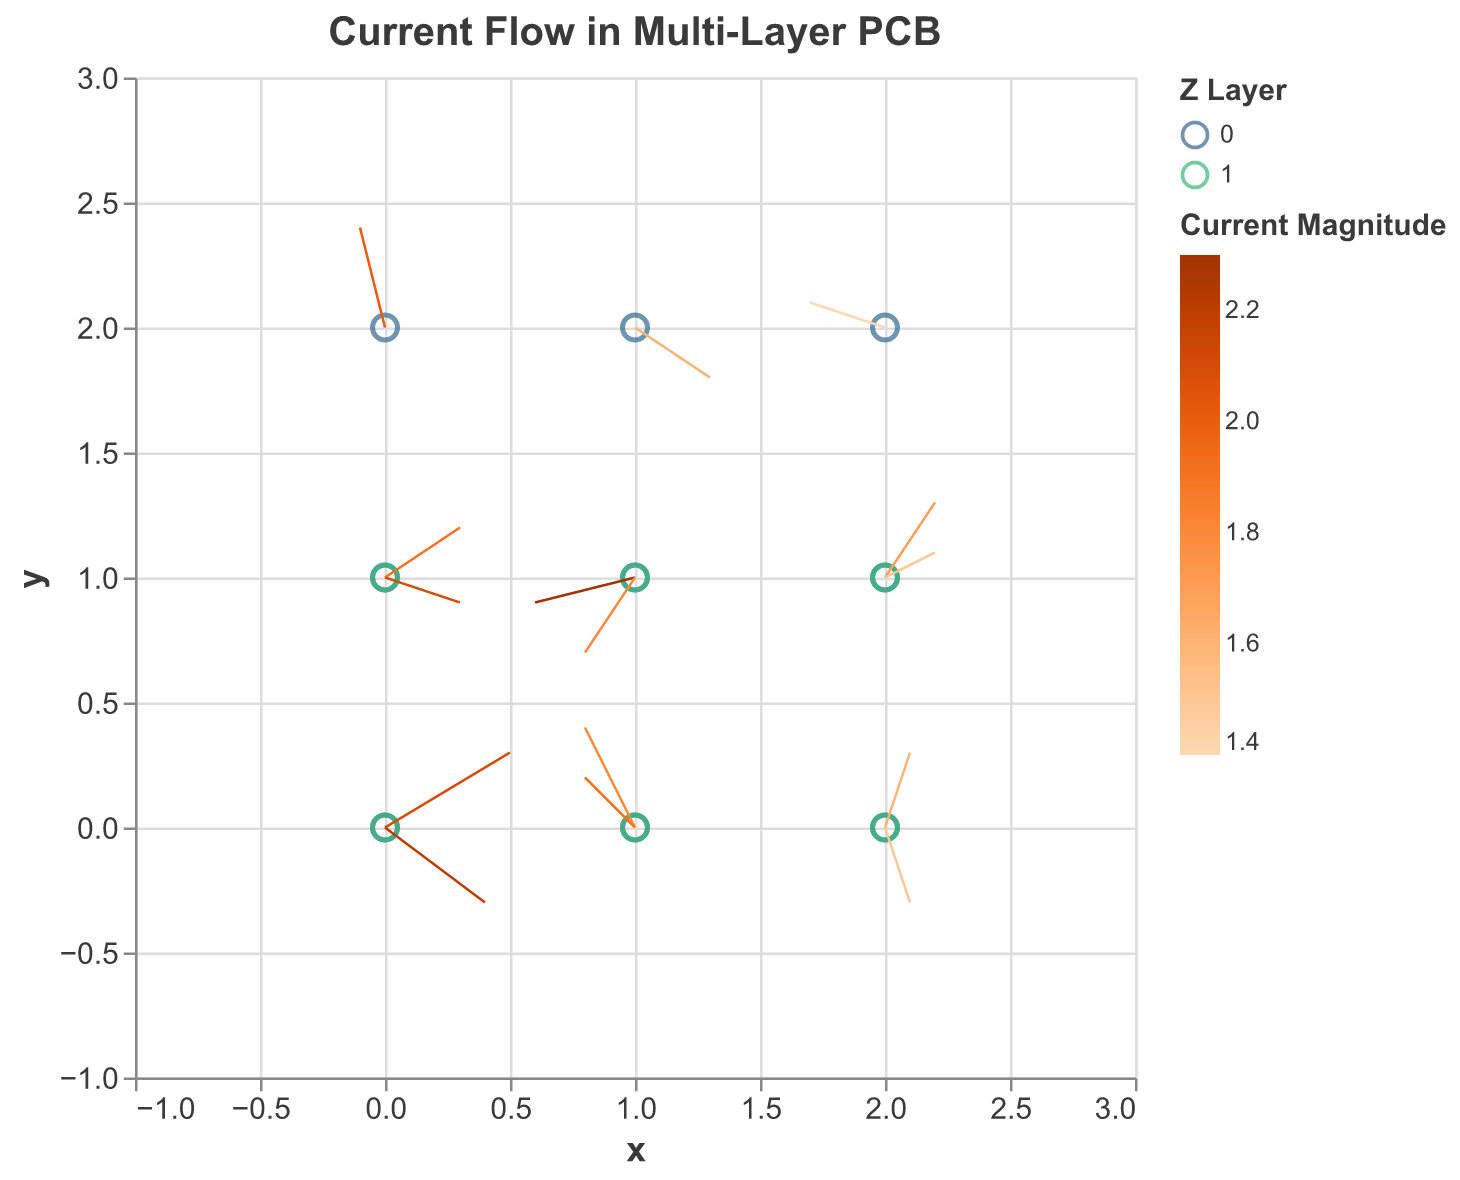What is the highest current magnitude shown in the figure? To identify the highest current magnitude, look at the color representing the magnitude values in the legend. The magnitude values for each arrow vary, but the highest value is 2.3, as indicated by the corresponding color shade in the plot.
Answer: 2.3 Which layer has the most points represented? There are three unique layers (z-values: 0, 1) as shown by the 'Z Layer' color legend. Both layers visually appear to have an equal number of points (each grid position corresponding to a different z-coordinate). Each layer has 7 data points.
Answer: 7 What is the general direction of current flow in the top layer (z = 1)? To determine the general direction of the current flow in the top layer, observe the directional arrows at points where z = 1. These arrows show varied directions, including positive and negative x, y, and z components.
Answer: Varied directions Compare the magnitudes of current flows at the point (1, 1) in both layers. Which one is higher? Check the current magnitudes at point (1, 1) for z = 0 and z = 1. The magnitudes are 2.3 for z = 0, and 1.8 for z = 1. As 2.3 > 1.8, the lower layer (z = 0) has a higher magnitude at (1, 1).
Answer: z = 0 What is the current direction and magnitude at (0, 0) in the bottom layer (z = 0)? Locate the vector at (0, 0) in the bottom layer (z = 0). The direction is given by the components (0.5, 0.3, 0.1), and the magnitude is 2.1, based on the values provided.
Answer: Direction: (0.5, 0.3, 0.1), Magnitude: 2.1 Which point has the smallest current magnitude value in the bottom layer (z = 0)? Check the current magnitudes for all points in the bottom layer (z = 0). The smallest magnitude among them is 1.4, located at point (2, 2).
Answer: (2, 2) At the point (2, 1) in the top layer (z = 1), what are the x and y components of the current flow? Look at the values associated with the point (2, 1, z=1). The x-component is 0.2 and the y-component is 0.1 as extracted from the dataset.
Answer: x: 0.2, y: 0.1 Calculate the average current magnitude in the bottom layer (z = 0). Identify and sum all magnitudes in the bottom layer (z = 0). There are 9 points: 2.1, 1.8, 1.5, 1.9, 2.3, 1.7, 2.0, 1.6, and 1.4. The sum is 2.1 + 1.8 + 1.5 + 1.9 + 2.3 + 1.7 + 2.0 + 1.6 + 1.4 = 16.3. Divided by 9, the average magnitude is 16.3/9 ≈ 1.81.
Answer: ~1.81 